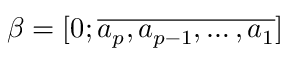Convert formula to latex. <formula><loc_0><loc_0><loc_500><loc_500>\beta = [ 0 ; \overline { { a _ { p } , a _ { p - 1 } , \dots , a _ { 1 } } } ]</formula> 